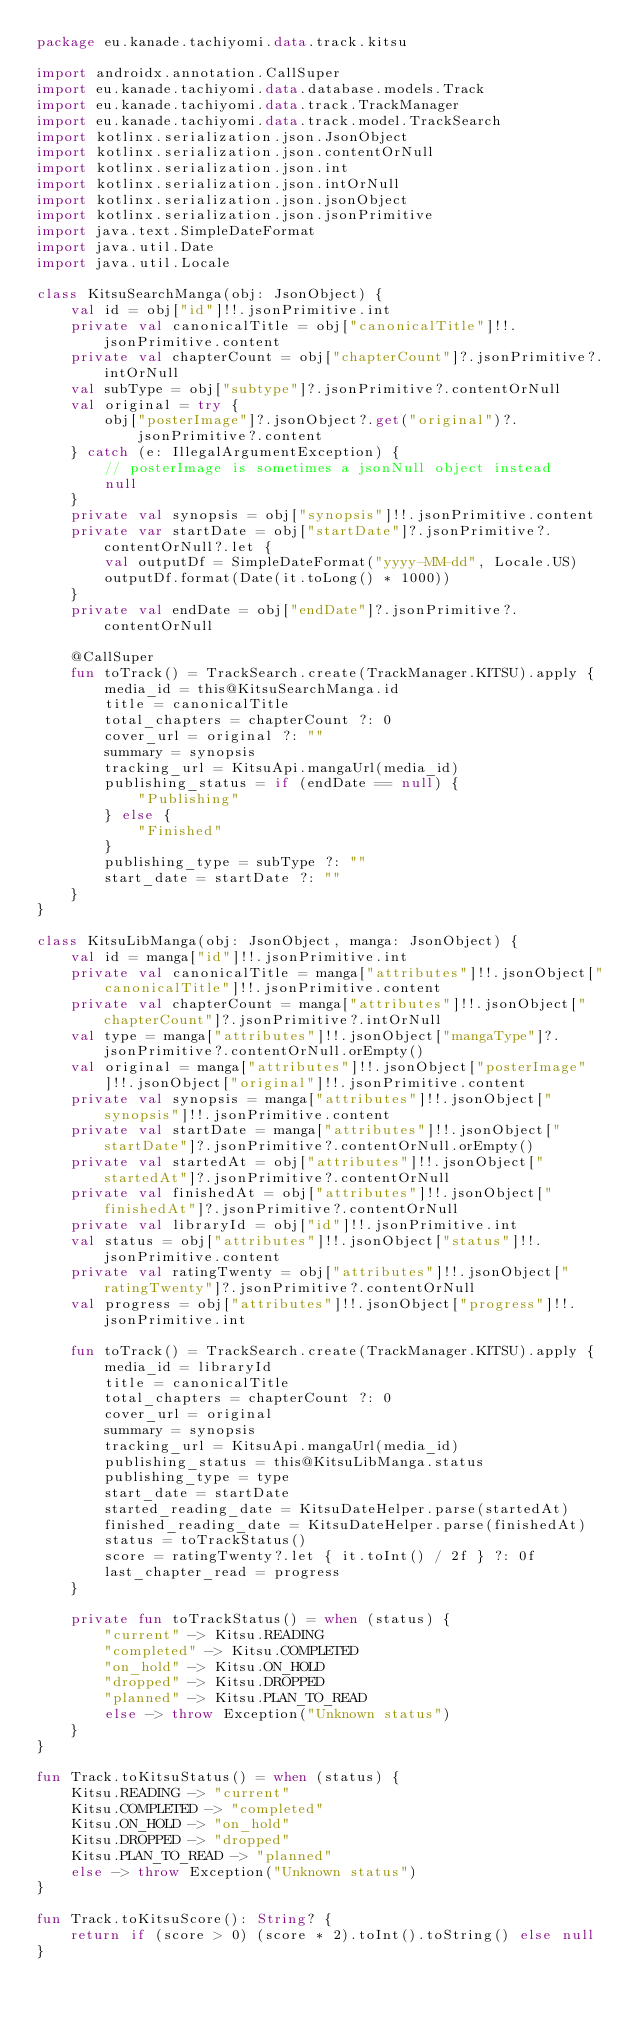<code> <loc_0><loc_0><loc_500><loc_500><_Kotlin_>package eu.kanade.tachiyomi.data.track.kitsu

import androidx.annotation.CallSuper
import eu.kanade.tachiyomi.data.database.models.Track
import eu.kanade.tachiyomi.data.track.TrackManager
import eu.kanade.tachiyomi.data.track.model.TrackSearch
import kotlinx.serialization.json.JsonObject
import kotlinx.serialization.json.contentOrNull
import kotlinx.serialization.json.int
import kotlinx.serialization.json.intOrNull
import kotlinx.serialization.json.jsonObject
import kotlinx.serialization.json.jsonPrimitive
import java.text.SimpleDateFormat
import java.util.Date
import java.util.Locale

class KitsuSearchManga(obj: JsonObject) {
    val id = obj["id"]!!.jsonPrimitive.int
    private val canonicalTitle = obj["canonicalTitle"]!!.jsonPrimitive.content
    private val chapterCount = obj["chapterCount"]?.jsonPrimitive?.intOrNull
    val subType = obj["subtype"]?.jsonPrimitive?.contentOrNull
    val original = try {
        obj["posterImage"]?.jsonObject?.get("original")?.jsonPrimitive?.content
    } catch (e: IllegalArgumentException) {
        // posterImage is sometimes a jsonNull object instead
        null
    }
    private val synopsis = obj["synopsis"]!!.jsonPrimitive.content
    private var startDate = obj["startDate"]?.jsonPrimitive?.contentOrNull?.let {
        val outputDf = SimpleDateFormat("yyyy-MM-dd", Locale.US)
        outputDf.format(Date(it.toLong() * 1000))
    }
    private val endDate = obj["endDate"]?.jsonPrimitive?.contentOrNull

    @CallSuper
    fun toTrack() = TrackSearch.create(TrackManager.KITSU).apply {
        media_id = this@KitsuSearchManga.id
        title = canonicalTitle
        total_chapters = chapterCount ?: 0
        cover_url = original ?: ""
        summary = synopsis
        tracking_url = KitsuApi.mangaUrl(media_id)
        publishing_status = if (endDate == null) {
            "Publishing"
        } else {
            "Finished"
        }
        publishing_type = subType ?: ""
        start_date = startDate ?: ""
    }
}

class KitsuLibManga(obj: JsonObject, manga: JsonObject) {
    val id = manga["id"]!!.jsonPrimitive.int
    private val canonicalTitle = manga["attributes"]!!.jsonObject["canonicalTitle"]!!.jsonPrimitive.content
    private val chapterCount = manga["attributes"]!!.jsonObject["chapterCount"]?.jsonPrimitive?.intOrNull
    val type = manga["attributes"]!!.jsonObject["mangaType"]?.jsonPrimitive?.contentOrNull.orEmpty()
    val original = manga["attributes"]!!.jsonObject["posterImage"]!!.jsonObject["original"]!!.jsonPrimitive.content
    private val synopsis = manga["attributes"]!!.jsonObject["synopsis"]!!.jsonPrimitive.content
    private val startDate = manga["attributes"]!!.jsonObject["startDate"]?.jsonPrimitive?.contentOrNull.orEmpty()
    private val startedAt = obj["attributes"]!!.jsonObject["startedAt"]?.jsonPrimitive?.contentOrNull
    private val finishedAt = obj["attributes"]!!.jsonObject["finishedAt"]?.jsonPrimitive?.contentOrNull
    private val libraryId = obj["id"]!!.jsonPrimitive.int
    val status = obj["attributes"]!!.jsonObject["status"]!!.jsonPrimitive.content
    private val ratingTwenty = obj["attributes"]!!.jsonObject["ratingTwenty"]?.jsonPrimitive?.contentOrNull
    val progress = obj["attributes"]!!.jsonObject["progress"]!!.jsonPrimitive.int

    fun toTrack() = TrackSearch.create(TrackManager.KITSU).apply {
        media_id = libraryId
        title = canonicalTitle
        total_chapters = chapterCount ?: 0
        cover_url = original
        summary = synopsis
        tracking_url = KitsuApi.mangaUrl(media_id)
        publishing_status = this@KitsuLibManga.status
        publishing_type = type
        start_date = startDate
        started_reading_date = KitsuDateHelper.parse(startedAt)
        finished_reading_date = KitsuDateHelper.parse(finishedAt)
        status = toTrackStatus()
        score = ratingTwenty?.let { it.toInt() / 2f } ?: 0f
        last_chapter_read = progress
    }

    private fun toTrackStatus() = when (status) {
        "current" -> Kitsu.READING
        "completed" -> Kitsu.COMPLETED
        "on_hold" -> Kitsu.ON_HOLD
        "dropped" -> Kitsu.DROPPED
        "planned" -> Kitsu.PLAN_TO_READ
        else -> throw Exception("Unknown status")
    }
}

fun Track.toKitsuStatus() = when (status) {
    Kitsu.READING -> "current"
    Kitsu.COMPLETED -> "completed"
    Kitsu.ON_HOLD -> "on_hold"
    Kitsu.DROPPED -> "dropped"
    Kitsu.PLAN_TO_READ -> "planned"
    else -> throw Exception("Unknown status")
}

fun Track.toKitsuScore(): String? {
    return if (score > 0) (score * 2).toInt().toString() else null
}
</code> 